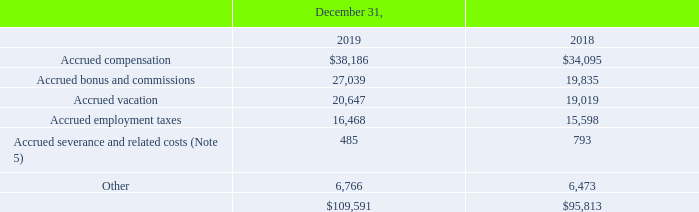Note 16. Accrued Employee Compensation and Benefits
Accrued employee compensation and benefits consisted of the following (in thousands):
What was the amount of Accrued severance and related costs in 2019?
Answer scale should be: thousand. 485. What was the amount of  Accrued employment taxes  in 2018?
Answer scale should be: thousand. 15,598. In which years were the Accrued employee compensation and benefits calculated? 2019, 2018. In which year was the amount of Other larger? 6,766>6,473
Answer: 2019. What was the change in Accrued severance and related costs in 2019 from 2018?
Answer scale should be: thousand. 485-793
Answer: -308. What was the percentage change in Accrued severance and related costs in 2019 from 2018?
Answer scale should be: percent. (485-793)/793
Answer: -38.84. 